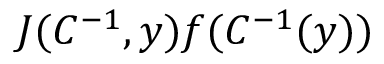Convert formula to latex. <formula><loc_0><loc_0><loc_500><loc_500>J ( C ^ { - 1 } , y ) f ( C ^ { - 1 } ( y ) )</formula> 